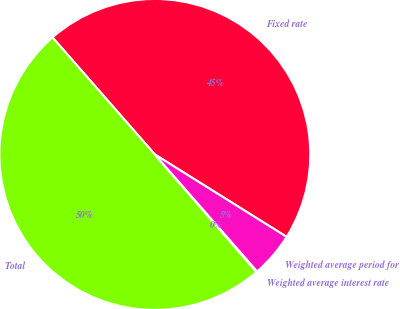Convert chart. <chart><loc_0><loc_0><loc_500><loc_500><pie_chart><fcel>Fixed rate<fcel>Total<fcel>Weighted average interest rate<fcel>Weighted average period for<nl><fcel>45.33%<fcel>49.91%<fcel>0.09%<fcel>4.67%<nl></chart> 